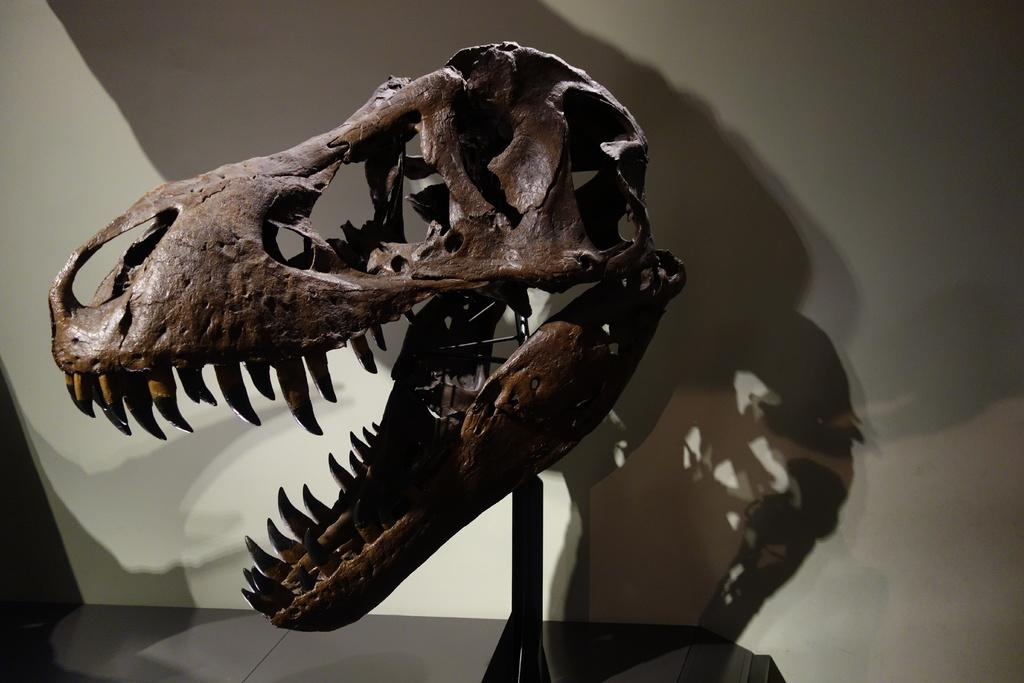What type of sculpture is in the image? There is a face sculpt of a Tyrannosaurus in the image. Can you describe any additional features related to the sculpture? There is a shadow of the sculpt on the wall in the image. What type of vessel is used to serve the lettuce in the image? There is no vessel or lettuce present in the image; it features a face sculpt of a Tyrannosaurus and its shadow on the wall. 